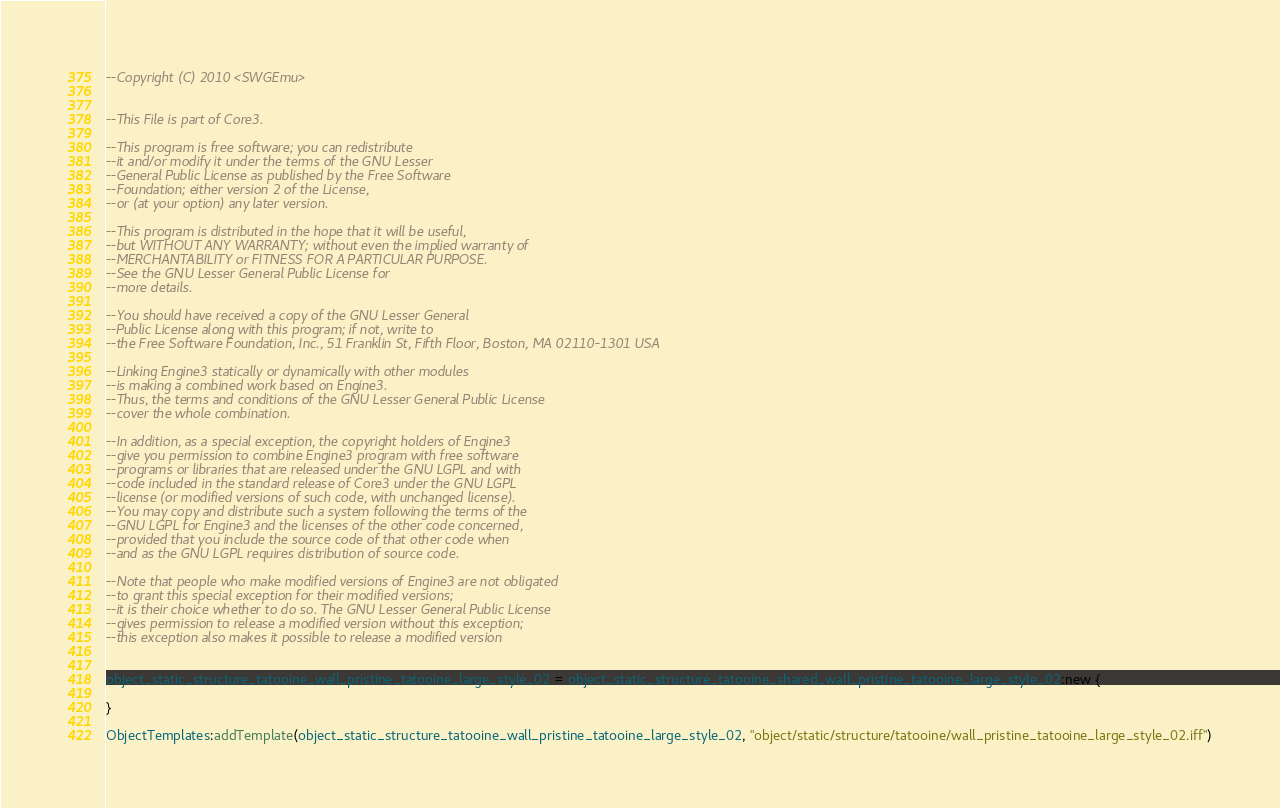<code> <loc_0><loc_0><loc_500><loc_500><_Lua_>--Copyright (C) 2010 <SWGEmu>


--This File is part of Core3.

--This program is free software; you can redistribute 
--it and/or modify it under the terms of the GNU Lesser 
--General Public License as published by the Free Software
--Foundation; either version 2 of the License, 
--or (at your option) any later version.

--This program is distributed in the hope that it will be useful, 
--but WITHOUT ANY WARRANTY; without even the implied warranty of 
--MERCHANTABILITY or FITNESS FOR A PARTICULAR PURPOSE. 
--See the GNU Lesser General Public License for
--more details.

--You should have received a copy of the GNU Lesser General 
--Public License along with this program; if not, write to
--the Free Software Foundation, Inc., 51 Franklin St, Fifth Floor, Boston, MA 02110-1301 USA

--Linking Engine3 statically or dynamically with other modules 
--is making a combined work based on Engine3. 
--Thus, the terms and conditions of the GNU Lesser General Public License 
--cover the whole combination.

--In addition, as a special exception, the copyright holders of Engine3 
--give you permission to combine Engine3 program with free software 
--programs or libraries that are released under the GNU LGPL and with 
--code included in the standard release of Core3 under the GNU LGPL 
--license (or modified versions of such code, with unchanged license). 
--You may copy and distribute such a system following the terms of the 
--GNU LGPL for Engine3 and the licenses of the other code concerned, 
--provided that you include the source code of that other code when 
--and as the GNU LGPL requires distribution of source code.

--Note that people who make modified versions of Engine3 are not obligated 
--to grant this special exception for their modified versions; 
--it is their choice whether to do so. The GNU Lesser General Public License 
--gives permission to release a modified version without this exception; 
--this exception also makes it possible to release a modified version 


object_static_structure_tatooine_wall_pristine_tatooine_large_style_02 = object_static_structure_tatooine_shared_wall_pristine_tatooine_large_style_02:new {

}

ObjectTemplates:addTemplate(object_static_structure_tatooine_wall_pristine_tatooine_large_style_02, "object/static/structure/tatooine/wall_pristine_tatooine_large_style_02.iff")
</code> 